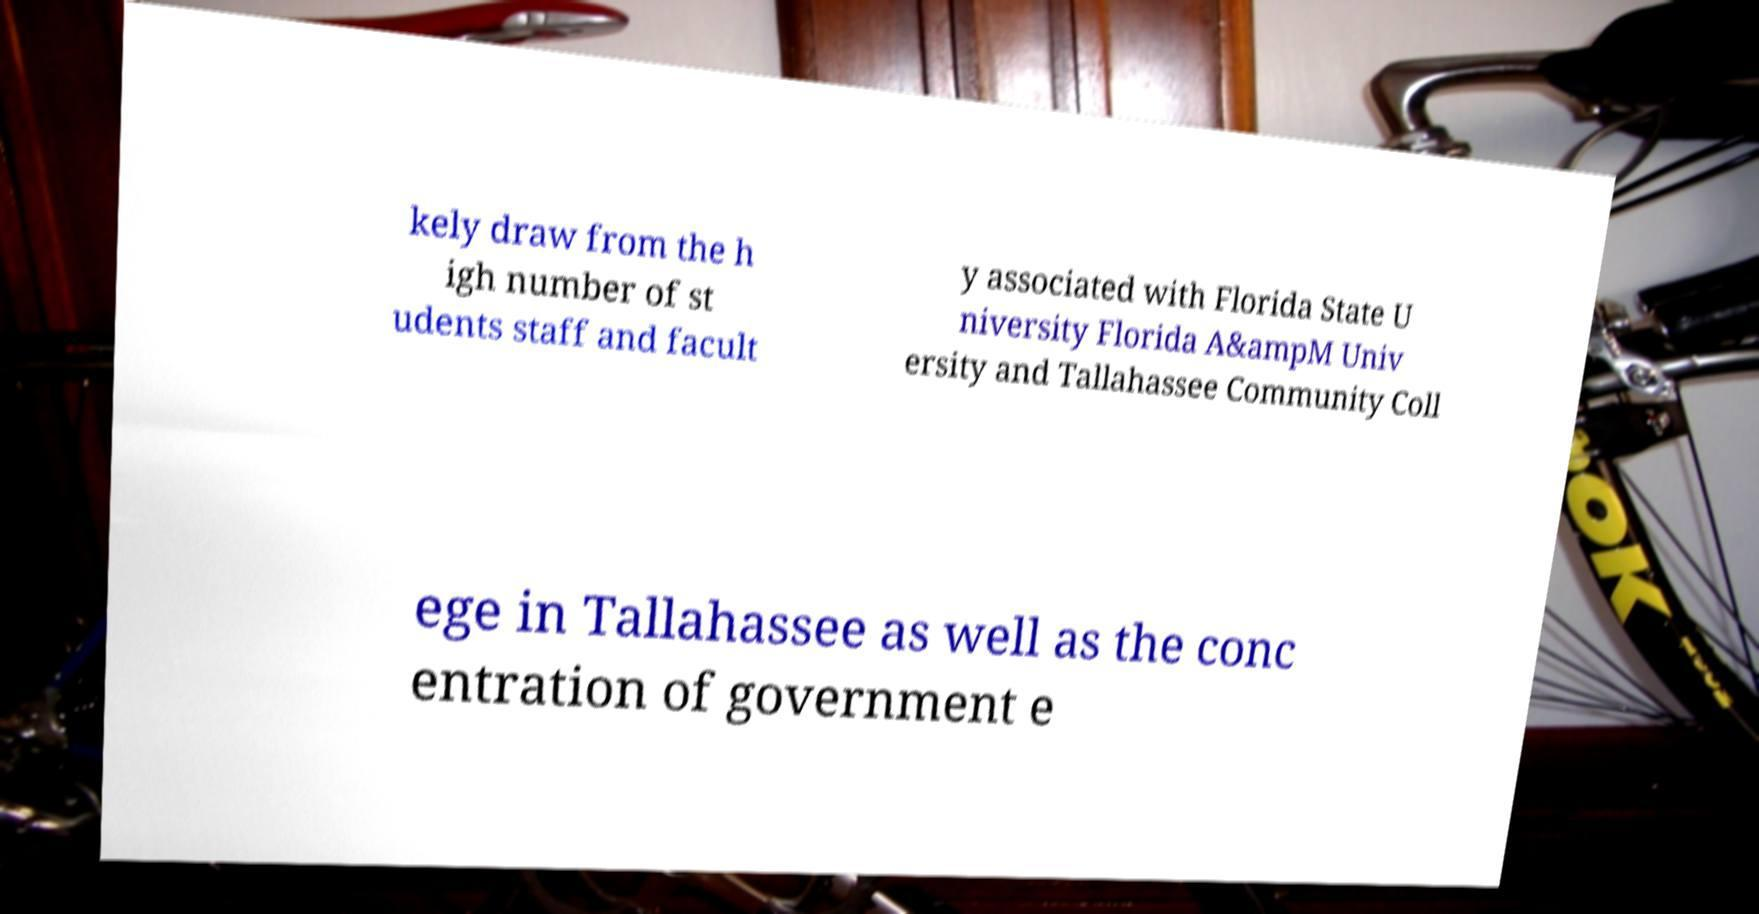Can you read and provide the text displayed in the image?This photo seems to have some interesting text. Can you extract and type it out for me? kely draw from the h igh number of st udents staff and facult y associated with Florida State U niversity Florida A&ampM Univ ersity and Tallahassee Community Coll ege in Tallahassee as well as the conc entration of government e 